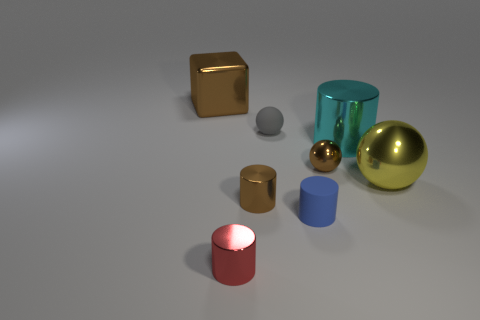There is a sphere that is the same color as the cube; what is its size?
Offer a terse response. Small. What size is the rubber thing that is in front of the yellow metal thing?
Your answer should be very brief. Small. There is a ball that is the same color as the big metallic block; what material is it?
Provide a short and direct response. Metal. The matte cylinder that is the same size as the red shiny thing is what color?
Give a very brief answer. Blue. Is the size of the shiny block the same as the yellow sphere?
Your answer should be compact. Yes. What size is the brown metal thing that is both behind the tiny brown cylinder and in front of the small matte sphere?
Your answer should be very brief. Small. What number of matte objects are small brown objects or tiny blue cylinders?
Make the answer very short. 1. Are there more shiny cubes in front of the cyan shiny cylinder than tiny red things?
Your response must be concise. No. There is a object that is in front of the tiny blue thing; what is its material?
Give a very brief answer. Metal. How many cyan blocks have the same material as the tiny brown cylinder?
Provide a succinct answer. 0. 